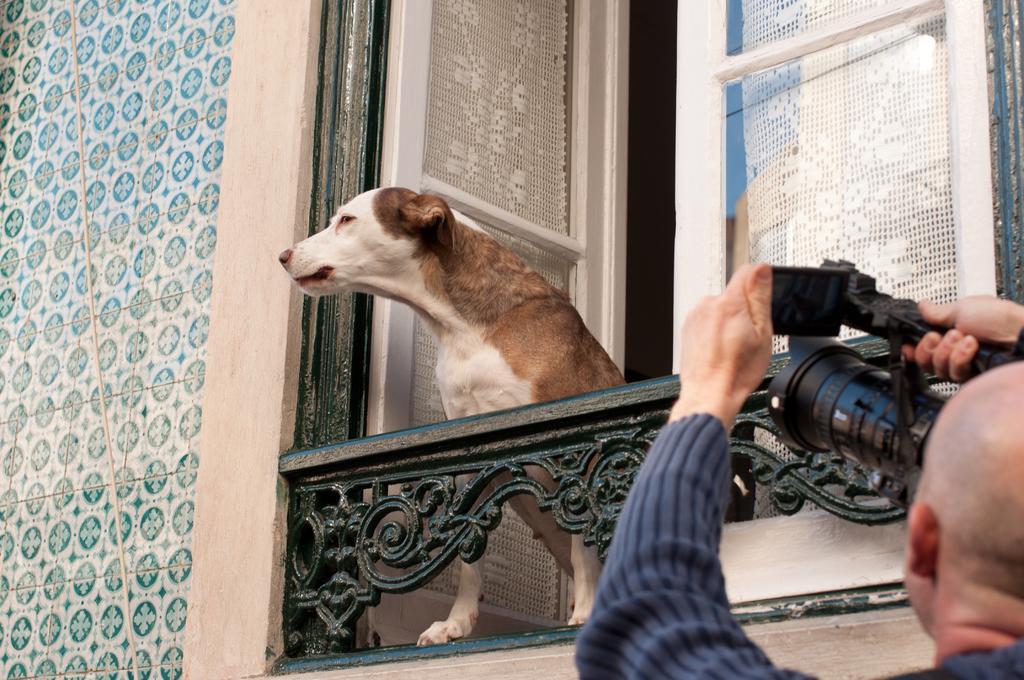How would you summarize this image in a sentence or two? This dog is looking outside from this window. In-front of this window a person is standing and holding a camera to capture this dog. 